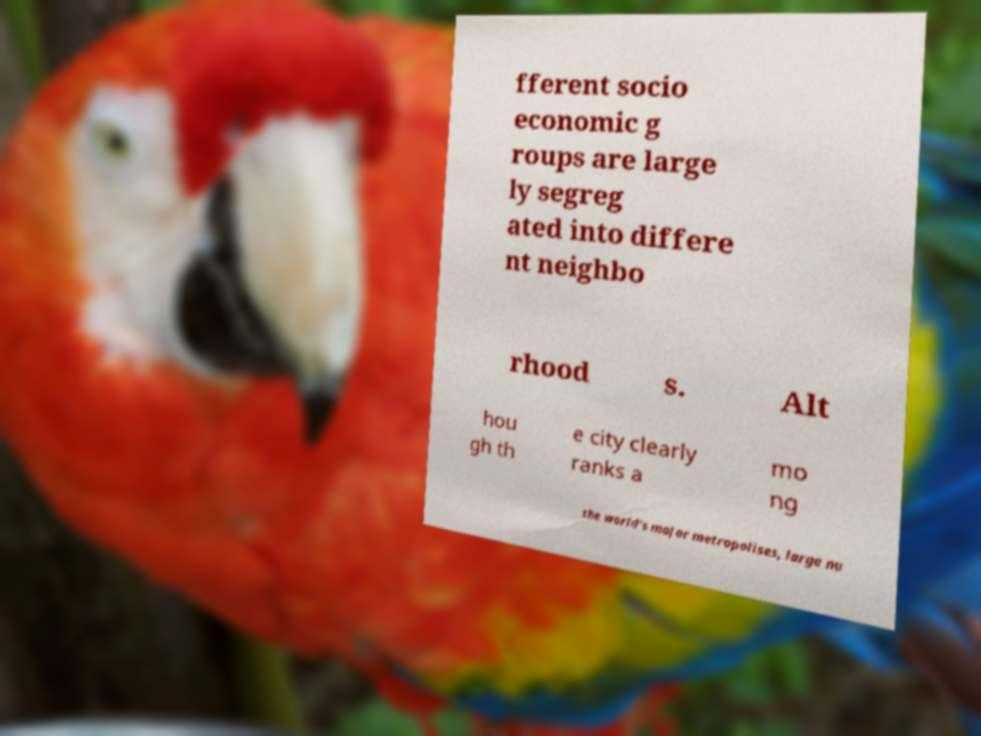There's text embedded in this image that I need extracted. Can you transcribe it verbatim? fferent socio economic g roups are large ly segreg ated into differe nt neighbo rhood s. Alt hou gh th e city clearly ranks a mo ng the world's major metropolises, large nu 